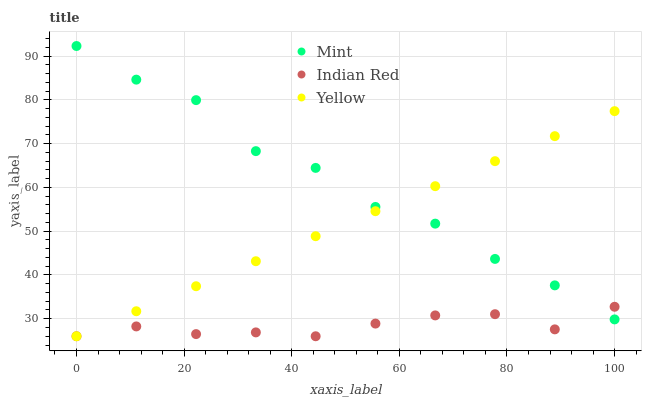Does Indian Red have the minimum area under the curve?
Answer yes or no. Yes. Does Mint have the maximum area under the curve?
Answer yes or no. Yes. Does Yellow have the minimum area under the curve?
Answer yes or no. No. Does Yellow have the maximum area under the curve?
Answer yes or no. No. Is Yellow the smoothest?
Answer yes or no. Yes. Is Mint the roughest?
Answer yes or no. Yes. Is Indian Red the smoothest?
Answer yes or no. No. Is Indian Red the roughest?
Answer yes or no. No. Does Yellow have the lowest value?
Answer yes or no. Yes. Does Mint have the highest value?
Answer yes or no. Yes. Does Yellow have the highest value?
Answer yes or no. No. Does Yellow intersect Indian Red?
Answer yes or no. Yes. Is Yellow less than Indian Red?
Answer yes or no. No. Is Yellow greater than Indian Red?
Answer yes or no. No. 